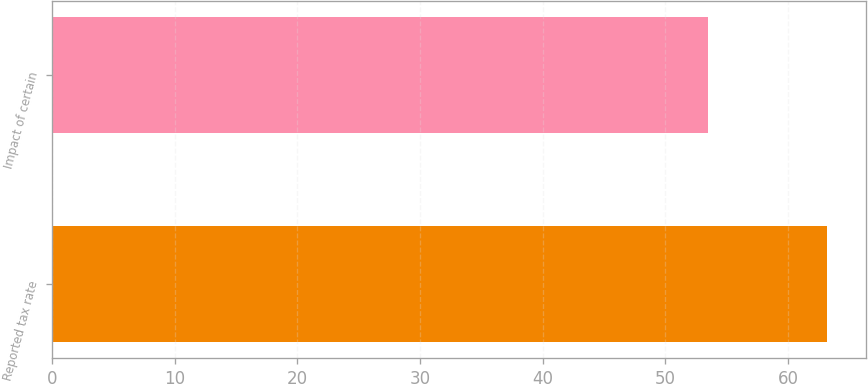Convert chart to OTSL. <chart><loc_0><loc_0><loc_500><loc_500><bar_chart><fcel>Reported tax rate<fcel>Impact of certain<nl><fcel>63.2<fcel>53.5<nl></chart> 